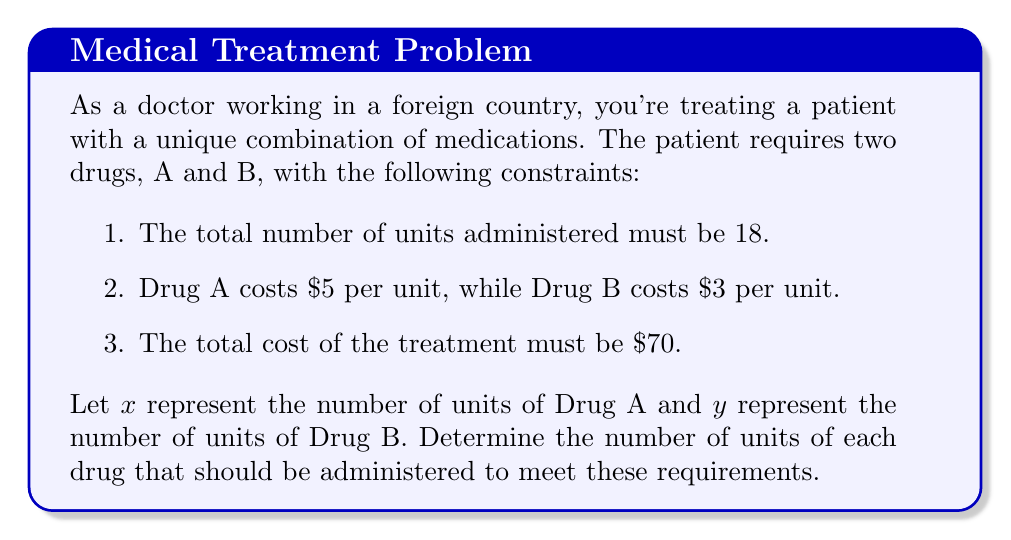Show me your answer to this math problem. Let's solve this problem step-by-step using a system of equations:

1) First, we'll set up our system of equations based on the given information:

   Equation 1 (total units): $x + y = 18$
   Equation 2 (total cost): $5x + 3y = 70$

2) We'll use the substitution method to solve this system. Let's rearrange Equation 1:

   $y = 18 - x$

3) Now, substitute this expression for $y$ into Equation 2:

   $5x + 3(18 - x) = 70$

4) Simplify:

   $5x + 54 - 3x = 70$
   $2x + 54 = 70$

5) Subtract 54 from both sides:

   $2x = 16$

6) Divide both sides by 2:

   $x = 8$

7) Now that we know $x$, we can find $y$ using Equation 1:

   $y = 18 - x = 18 - 8 = 10$

8) Let's verify our solution satisfies both original equations:

   Equation 1: $8 + 10 = 18$ (✓)
   Equation 2: $5(8) + 3(10) = 40 + 30 = 70$ (✓)

Therefore, the optimal dosage is 8 units of Drug A and 10 units of Drug B.
Answer: Drug A: 8 units, Drug B: 10 units 